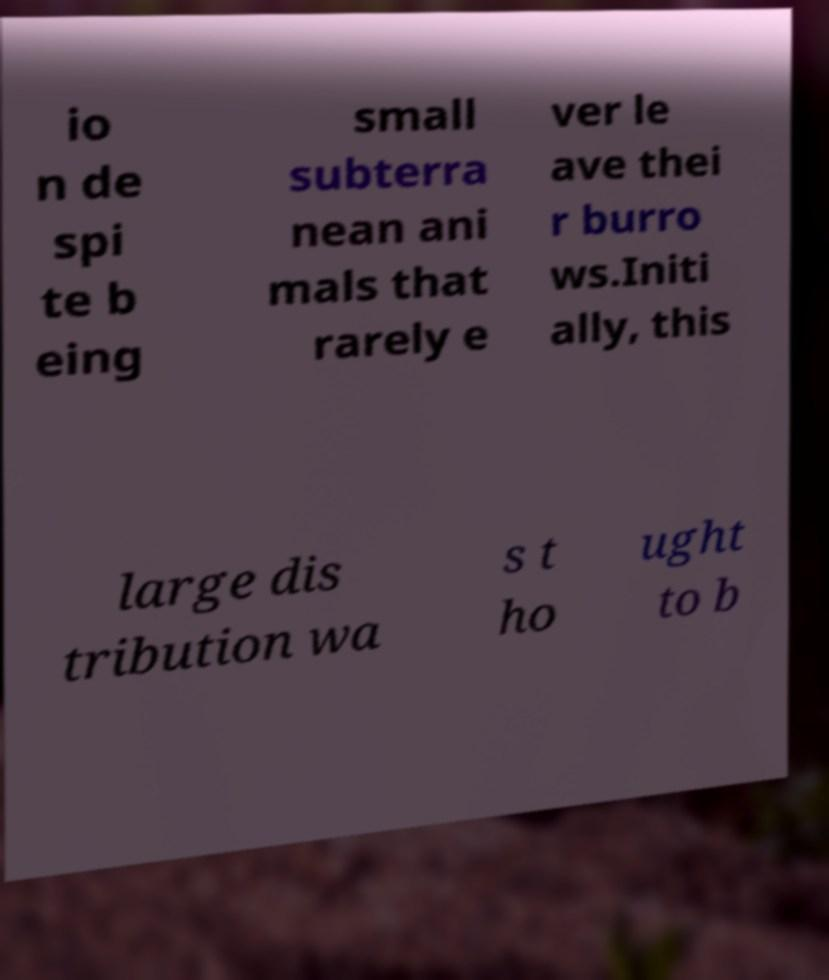Can you read and provide the text displayed in the image?This photo seems to have some interesting text. Can you extract and type it out for me? io n de spi te b eing small subterra nean ani mals that rarely e ver le ave thei r burro ws.Initi ally, this large dis tribution wa s t ho ught to b 